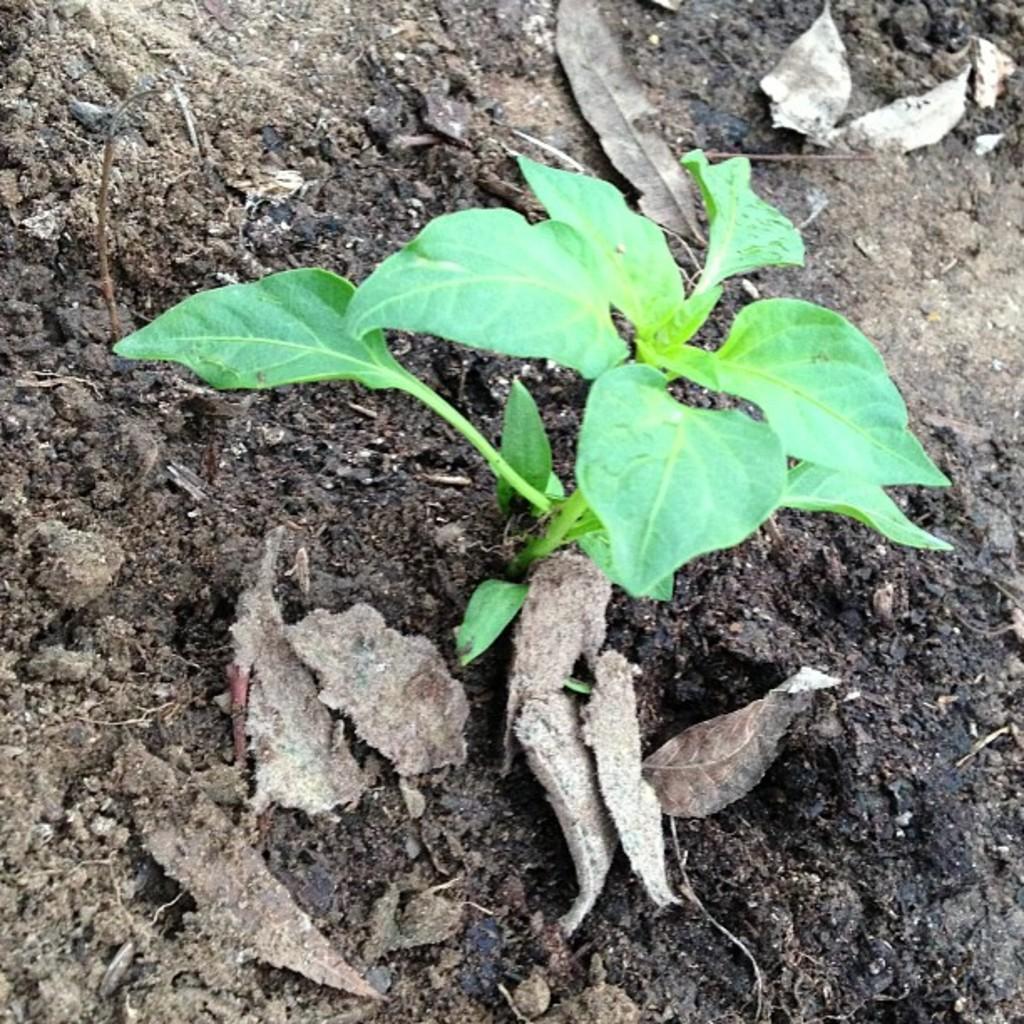In one or two sentences, can you explain what this image depicts? A small plant is budding out of black soil. There are some dry leaves around the plant. 